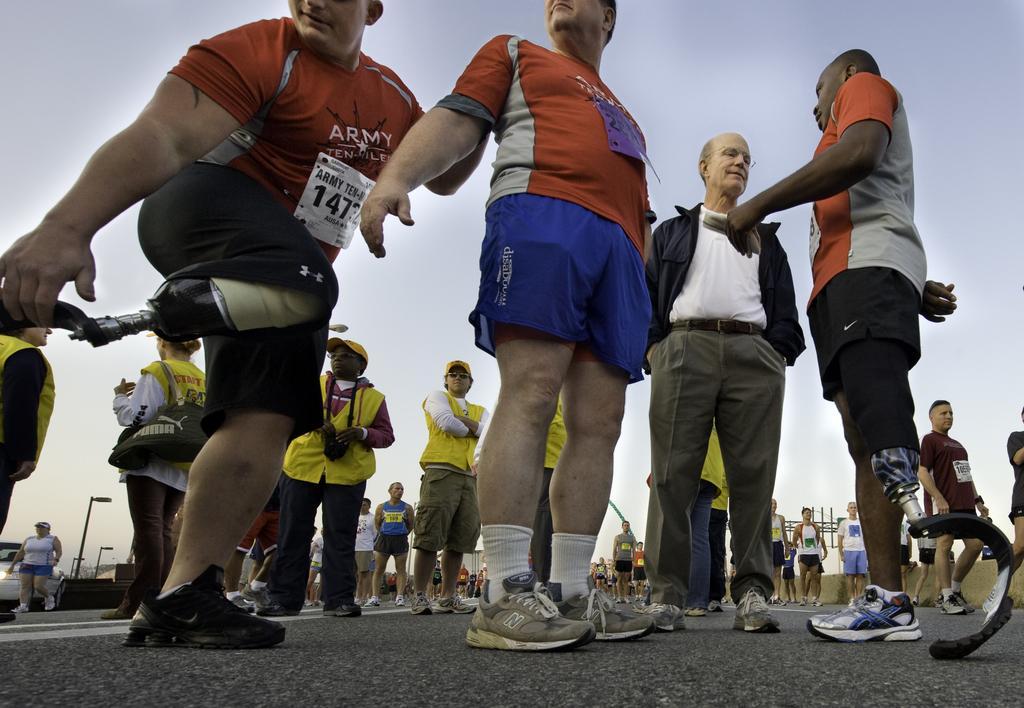Could you give a brief overview of what you see in this image? In the image I can see a some people who are wearing the shoes and also I can see a person with the synthetic leg. 